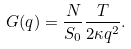Convert formula to latex. <formula><loc_0><loc_0><loc_500><loc_500>G ( q ) = \frac { N } { S _ { 0 } } \frac { T } { 2 \kappa q ^ { 2 } } .</formula> 